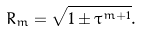<formula> <loc_0><loc_0><loc_500><loc_500>R _ { m } = \sqrt { 1 \pm \tau ^ { m + 1 } } .</formula> 